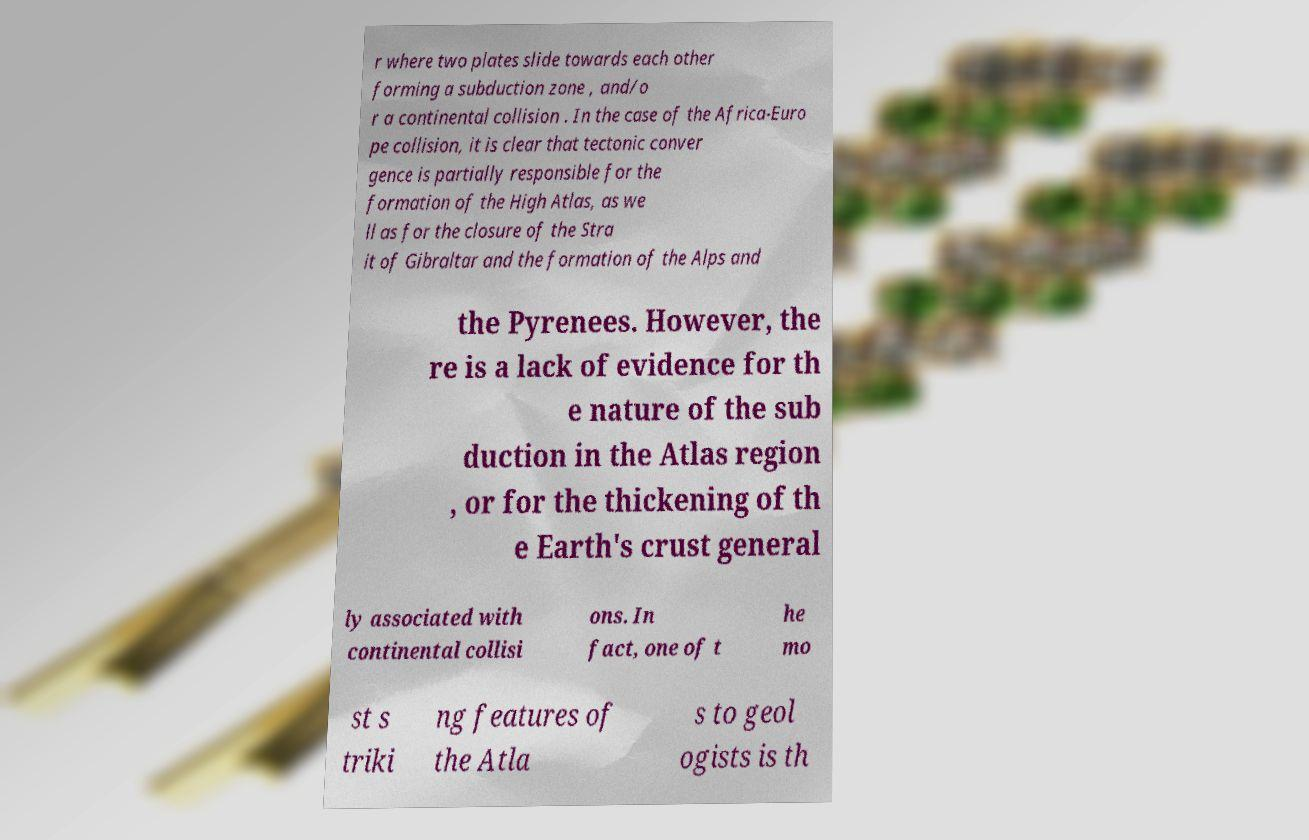Could you assist in decoding the text presented in this image and type it out clearly? r where two plates slide towards each other forming a subduction zone , and/o r a continental collision . In the case of the Africa-Euro pe collision, it is clear that tectonic conver gence is partially responsible for the formation of the High Atlas, as we ll as for the closure of the Stra it of Gibraltar and the formation of the Alps and the Pyrenees. However, the re is a lack of evidence for th e nature of the sub duction in the Atlas region , or for the thickening of th e Earth's crust general ly associated with continental collisi ons. In fact, one of t he mo st s triki ng features of the Atla s to geol ogists is th 